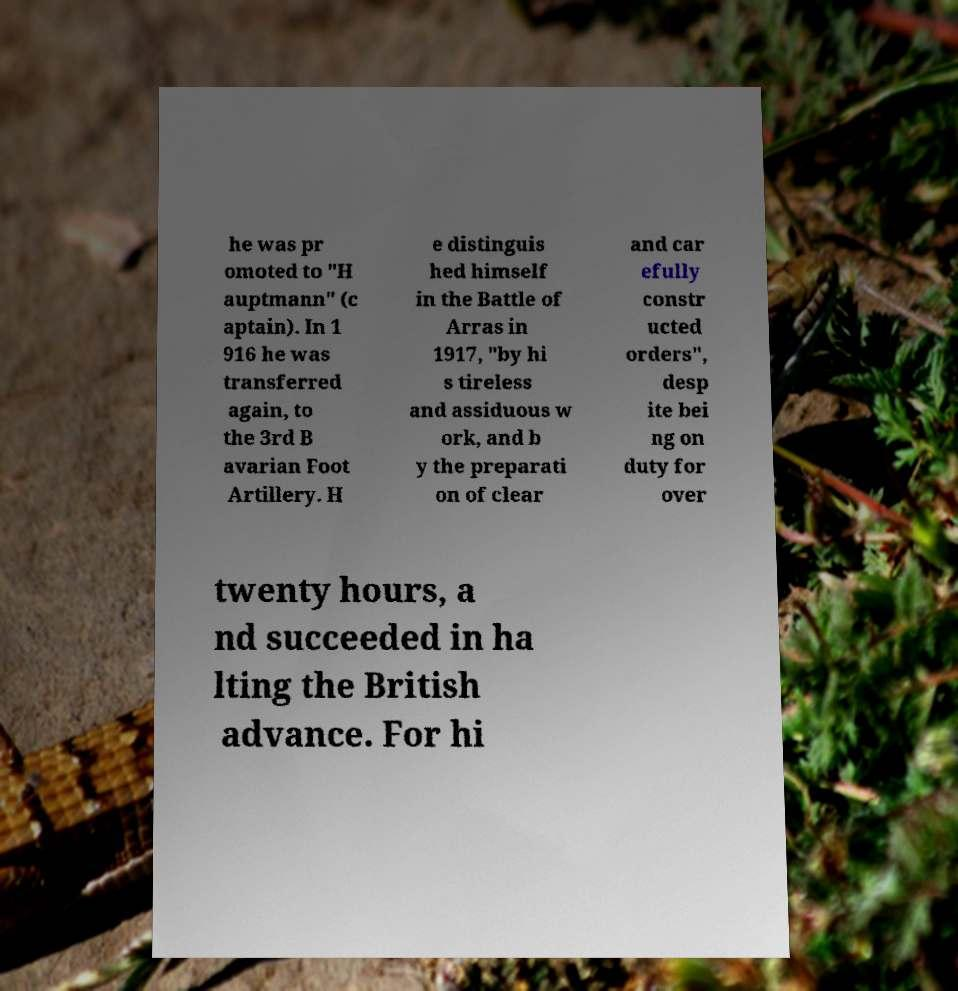Can you accurately transcribe the text from the provided image for me? he was pr omoted to "H auptmann" (c aptain). In 1 916 he was transferred again, to the 3rd B avarian Foot Artillery. H e distinguis hed himself in the Battle of Arras in 1917, "by hi s tireless and assiduous w ork, and b y the preparati on of clear and car efully constr ucted orders", desp ite bei ng on duty for over twenty hours, a nd succeeded in ha lting the British advance. For hi 